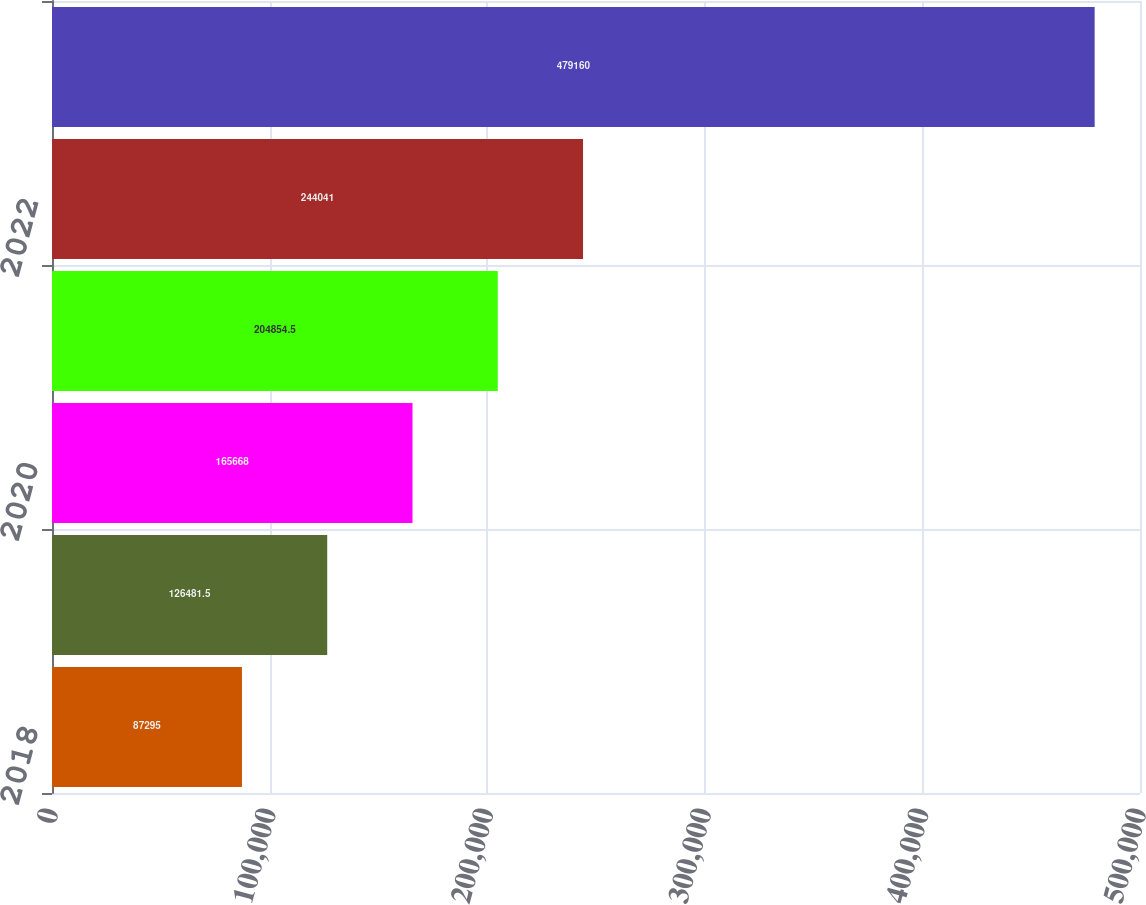Convert chart to OTSL. <chart><loc_0><loc_0><loc_500><loc_500><bar_chart><fcel>2018<fcel>2019<fcel>2020<fcel>2021<fcel>2022<fcel>2023 - 2027<nl><fcel>87295<fcel>126482<fcel>165668<fcel>204854<fcel>244041<fcel>479160<nl></chart> 